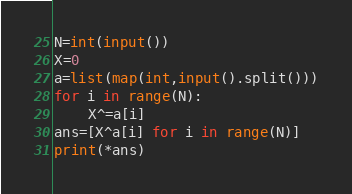<code> <loc_0><loc_0><loc_500><loc_500><_Python_>N=int(input())
X=0
a=list(map(int,input().split()))
for i in range(N):
    X^=a[i]
ans=[X^a[i] for i in range(N)]
print(*ans)
</code> 